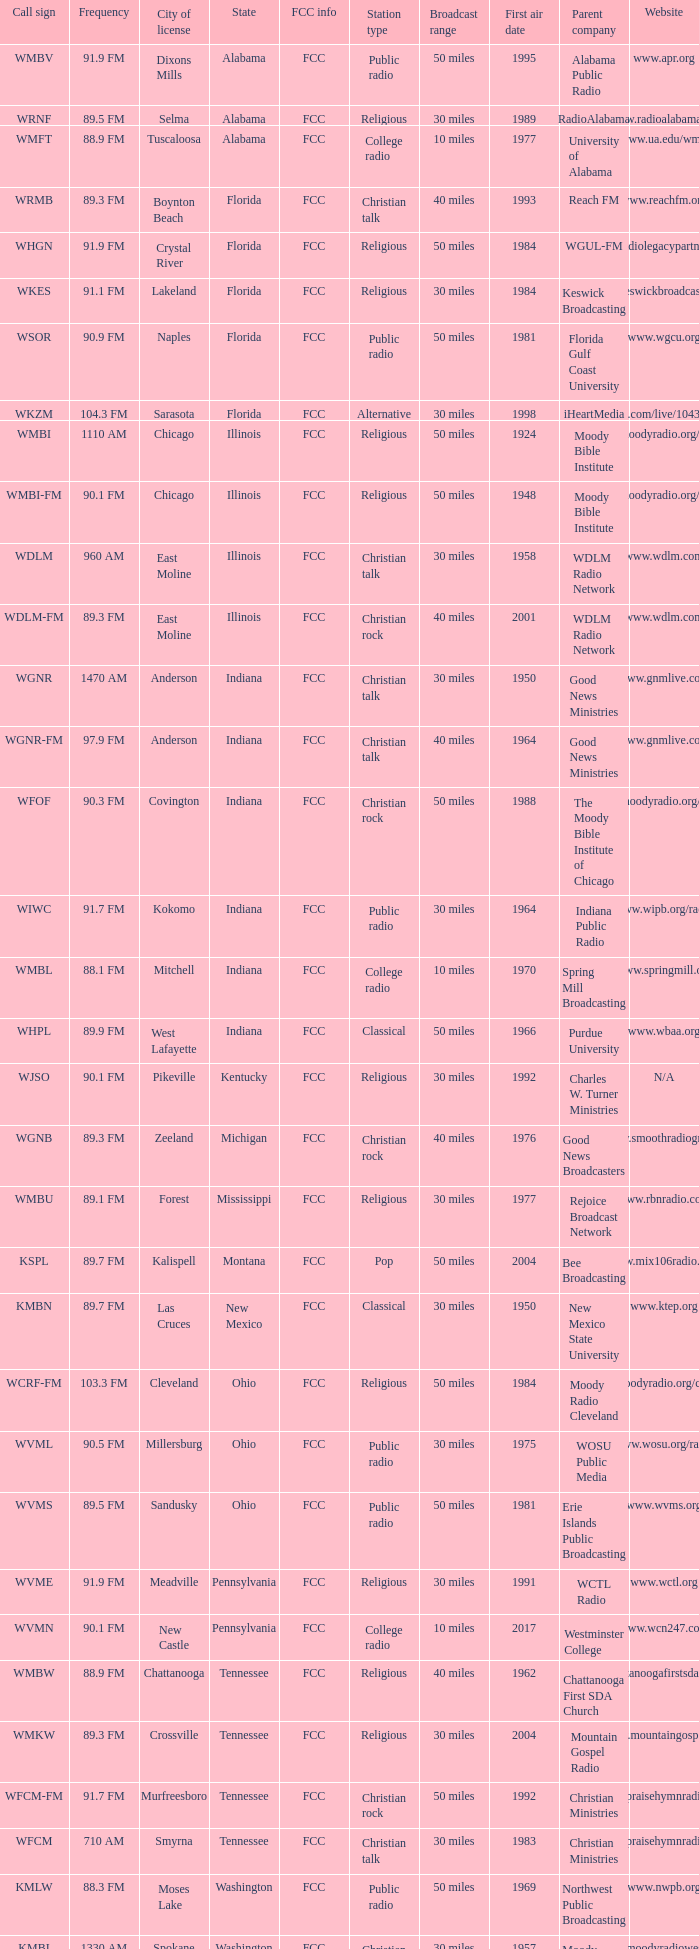What is the frequency of the radio station in Indiana that has a call sign of WGNR? 1470 AM. 